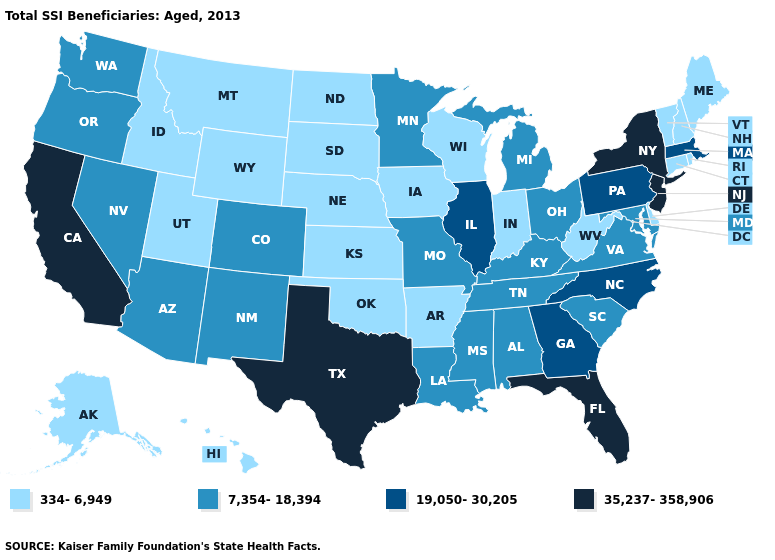What is the highest value in the West ?
Answer briefly. 35,237-358,906. Among the states that border Pennsylvania , which have the highest value?
Quick response, please. New Jersey, New York. Name the states that have a value in the range 19,050-30,205?
Give a very brief answer. Georgia, Illinois, Massachusetts, North Carolina, Pennsylvania. What is the value of Wyoming?
Answer briefly. 334-6,949. What is the value of West Virginia?
Keep it brief. 334-6,949. What is the value of North Dakota?
Give a very brief answer. 334-6,949. Does the first symbol in the legend represent the smallest category?
Concise answer only. Yes. Among the states that border Utah , does Nevada have the lowest value?
Give a very brief answer. No. What is the value of Wyoming?
Be succinct. 334-6,949. Name the states that have a value in the range 35,237-358,906?
Answer briefly. California, Florida, New Jersey, New York, Texas. What is the highest value in the USA?
Keep it brief. 35,237-358,906. What is the value of South Dakota?
Keep it brief. 334-6,949. Name the states that have a value in the range 35,237-358,906?
Be succinct. California, Florida, New Jersey, New York, Texas. What is the lowest value in states that border Vermont?
Concise answer only. 334-6,949. Does Utah have the lowest value in the West?
Give a very brief answer. Yes. 